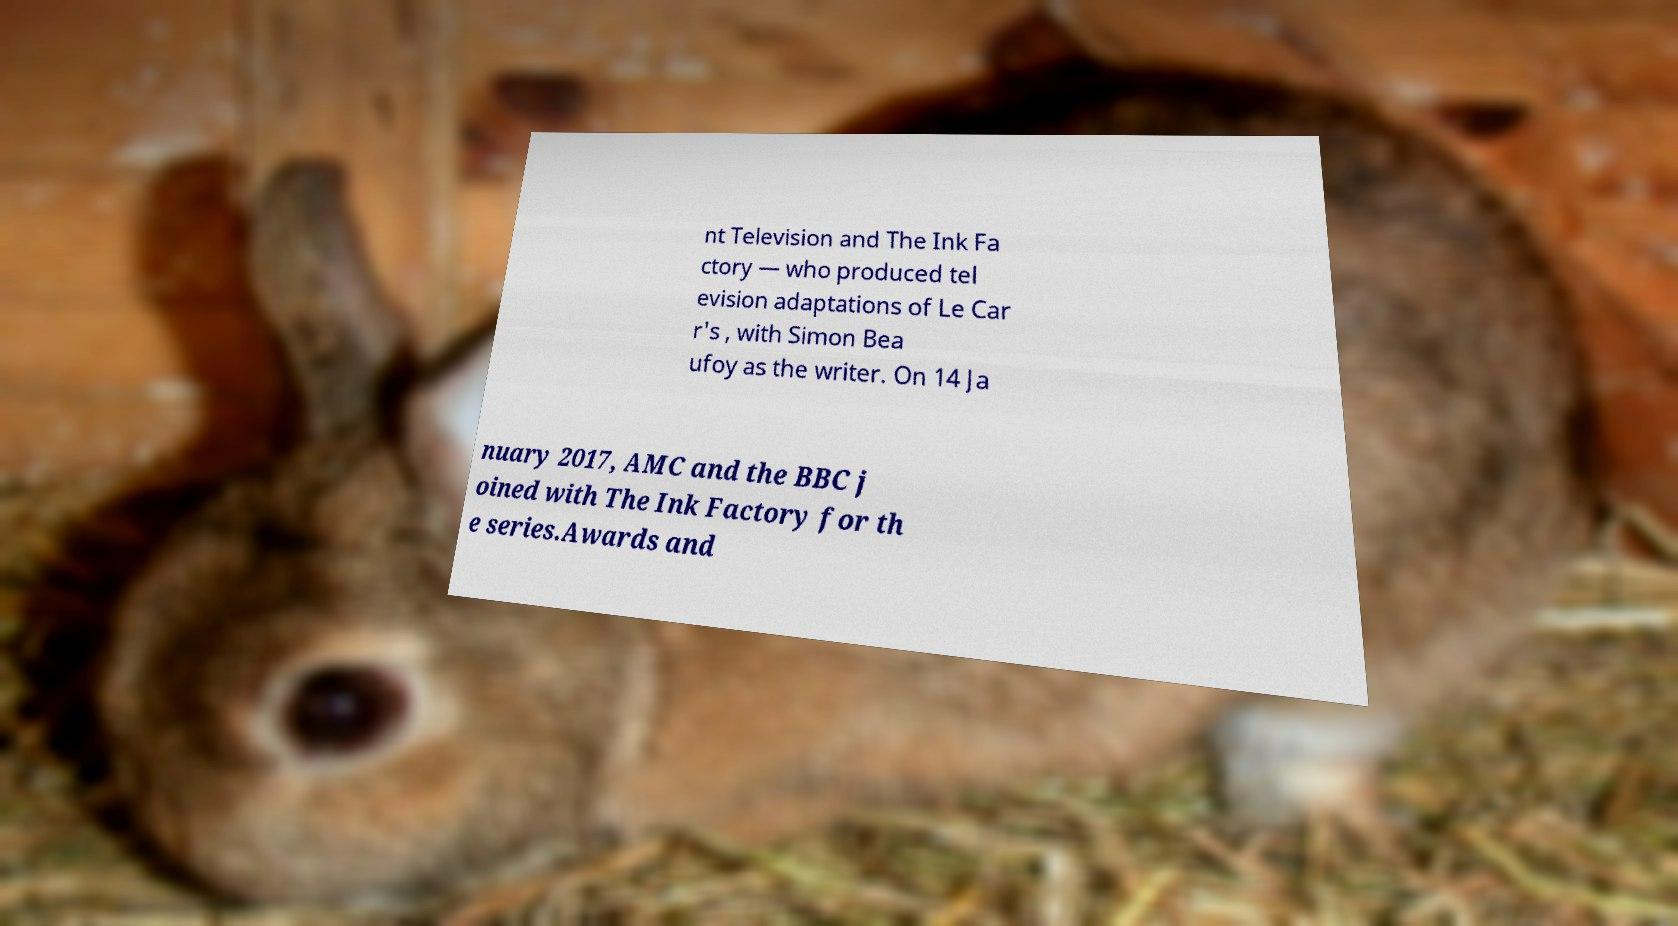Can you read and provide the text displayed in the image?This photo seems to have some interesting text. Can you extract and type it out for me? nt Television and The Ink Fa ctory — who produced tel evision adaptations of Le Car r's , with Simon Bea ufoy as the writer. On 14 Ja nuary 2017, AMC and the BBC j oined with The Ink Factory for th e series.Awards and 